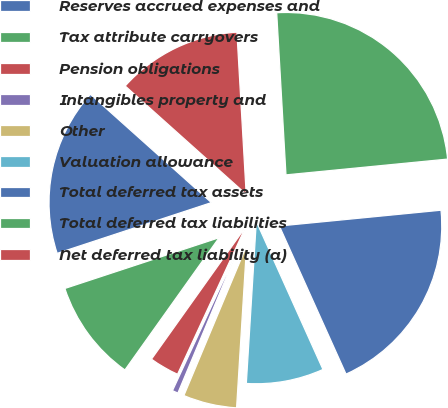<chart> <loc_0><loc_0><loc_500><loc_500><pie_chart><fcel>Reserves accrued expenses and<fcel>Tax attribute carryovers<fcel>Pension obligations<fcel>Intangibles property and<fcel>Other<fcel>Valuation allowance<fcel>Total deferred tax assets<fcel>Total deferred tax liabilities<fcel>Net deferred tax liability (a)<nl><fcel>16.68%<fcel>10.09%<fcel>2.96%<fcel>0.58%<fcel>5.33%<fcel>7.71%<fcel>19.82%<fcel>24.36%<fcel>12.47%<nl></chart> 